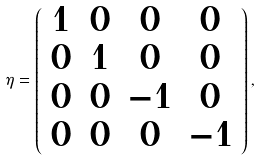Convert formula to latex. <formula><loc_0><loc_0><loc_500><loc_500>\eta = \left ( \begin{array} { c c c c } 1 & 0 & 0 & 0 \\ 0 & 1 & 0 & 0 \\ 0 & 0 & - 1 & 0 \\ 0 & 0 & 0 & - 1 \end{array} \right ) ,</formula> 